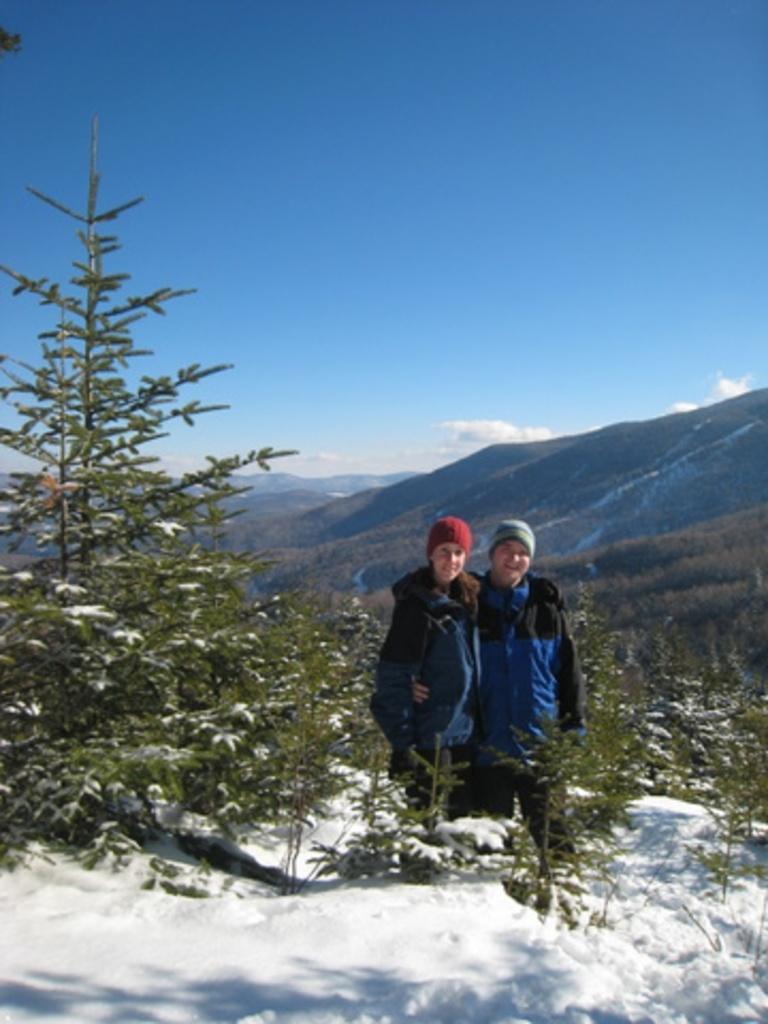Could you give a brief overview of what you see in this image? In this image in the center there are plants and there are persons standing and smiling. In the background there are mountains and the sky is cloudy. 